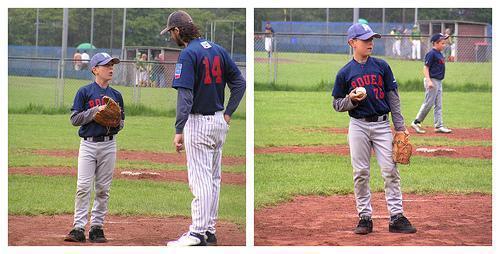How many pictures?
Give a very brief answer. 2. 